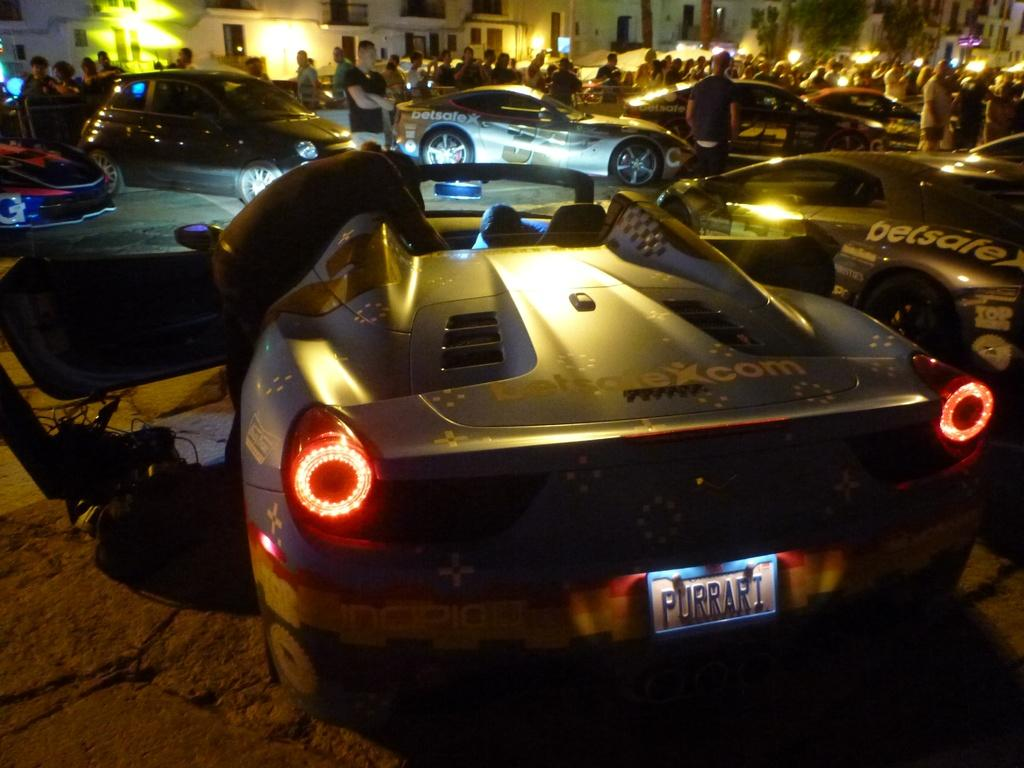What types of objects can be seen in the image? There are vehicles in the image. Are there any living beings present in the image? Yes, there are people in the image. What can be seen in the distance in the image? There are buildings in the background of the image. What type of disease is being treated in the image? There is no indication of a disease or any medical treatment in the image. How is the butter being used in the image? There is no butter present in the image. 